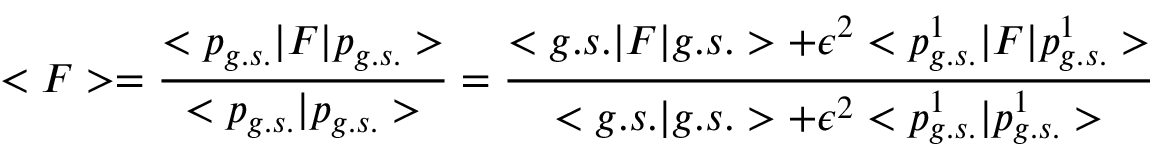Convert formula to latex. <formula><loc_0><loc_0><loc_500><loc_500>< F > = \frac { < p _ { g . s . } | F | p _ { g . s . } > } { < p _ { g . s . } | p _ { g . s . } > } = \frac { < g . s . | F | g . s . > + \epsilon ^ { 2 } < p _ { g . s . } ^ { 1 } | F | p _ { g . s . } ^ { 1 } > } { < g . s . | g . s . > + \epsilon ^ { 2 } < p _ { g . s . } ^ { 1 } | p _ { g . s . } ^ { 1 } > }</formula> 